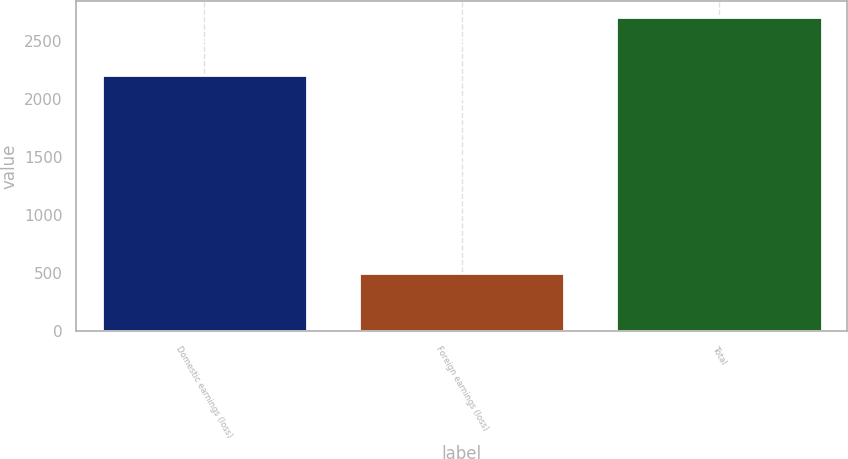<chart> <loc_0><loc_0><loc_500><loc_500><bar_chart><fcel>Domestic earnings (loss)<fcel>Foreign earnings (loss)<fcel>Total<nl><fcel>2204<fcel>503<fcel>2707<nl></chart> 